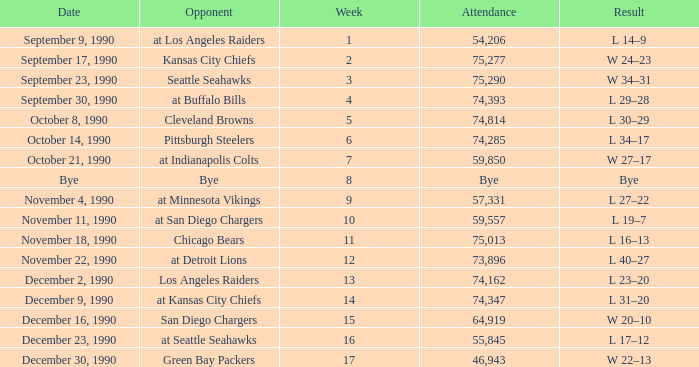What day was the attendance 74,285? October 14, 1990. 